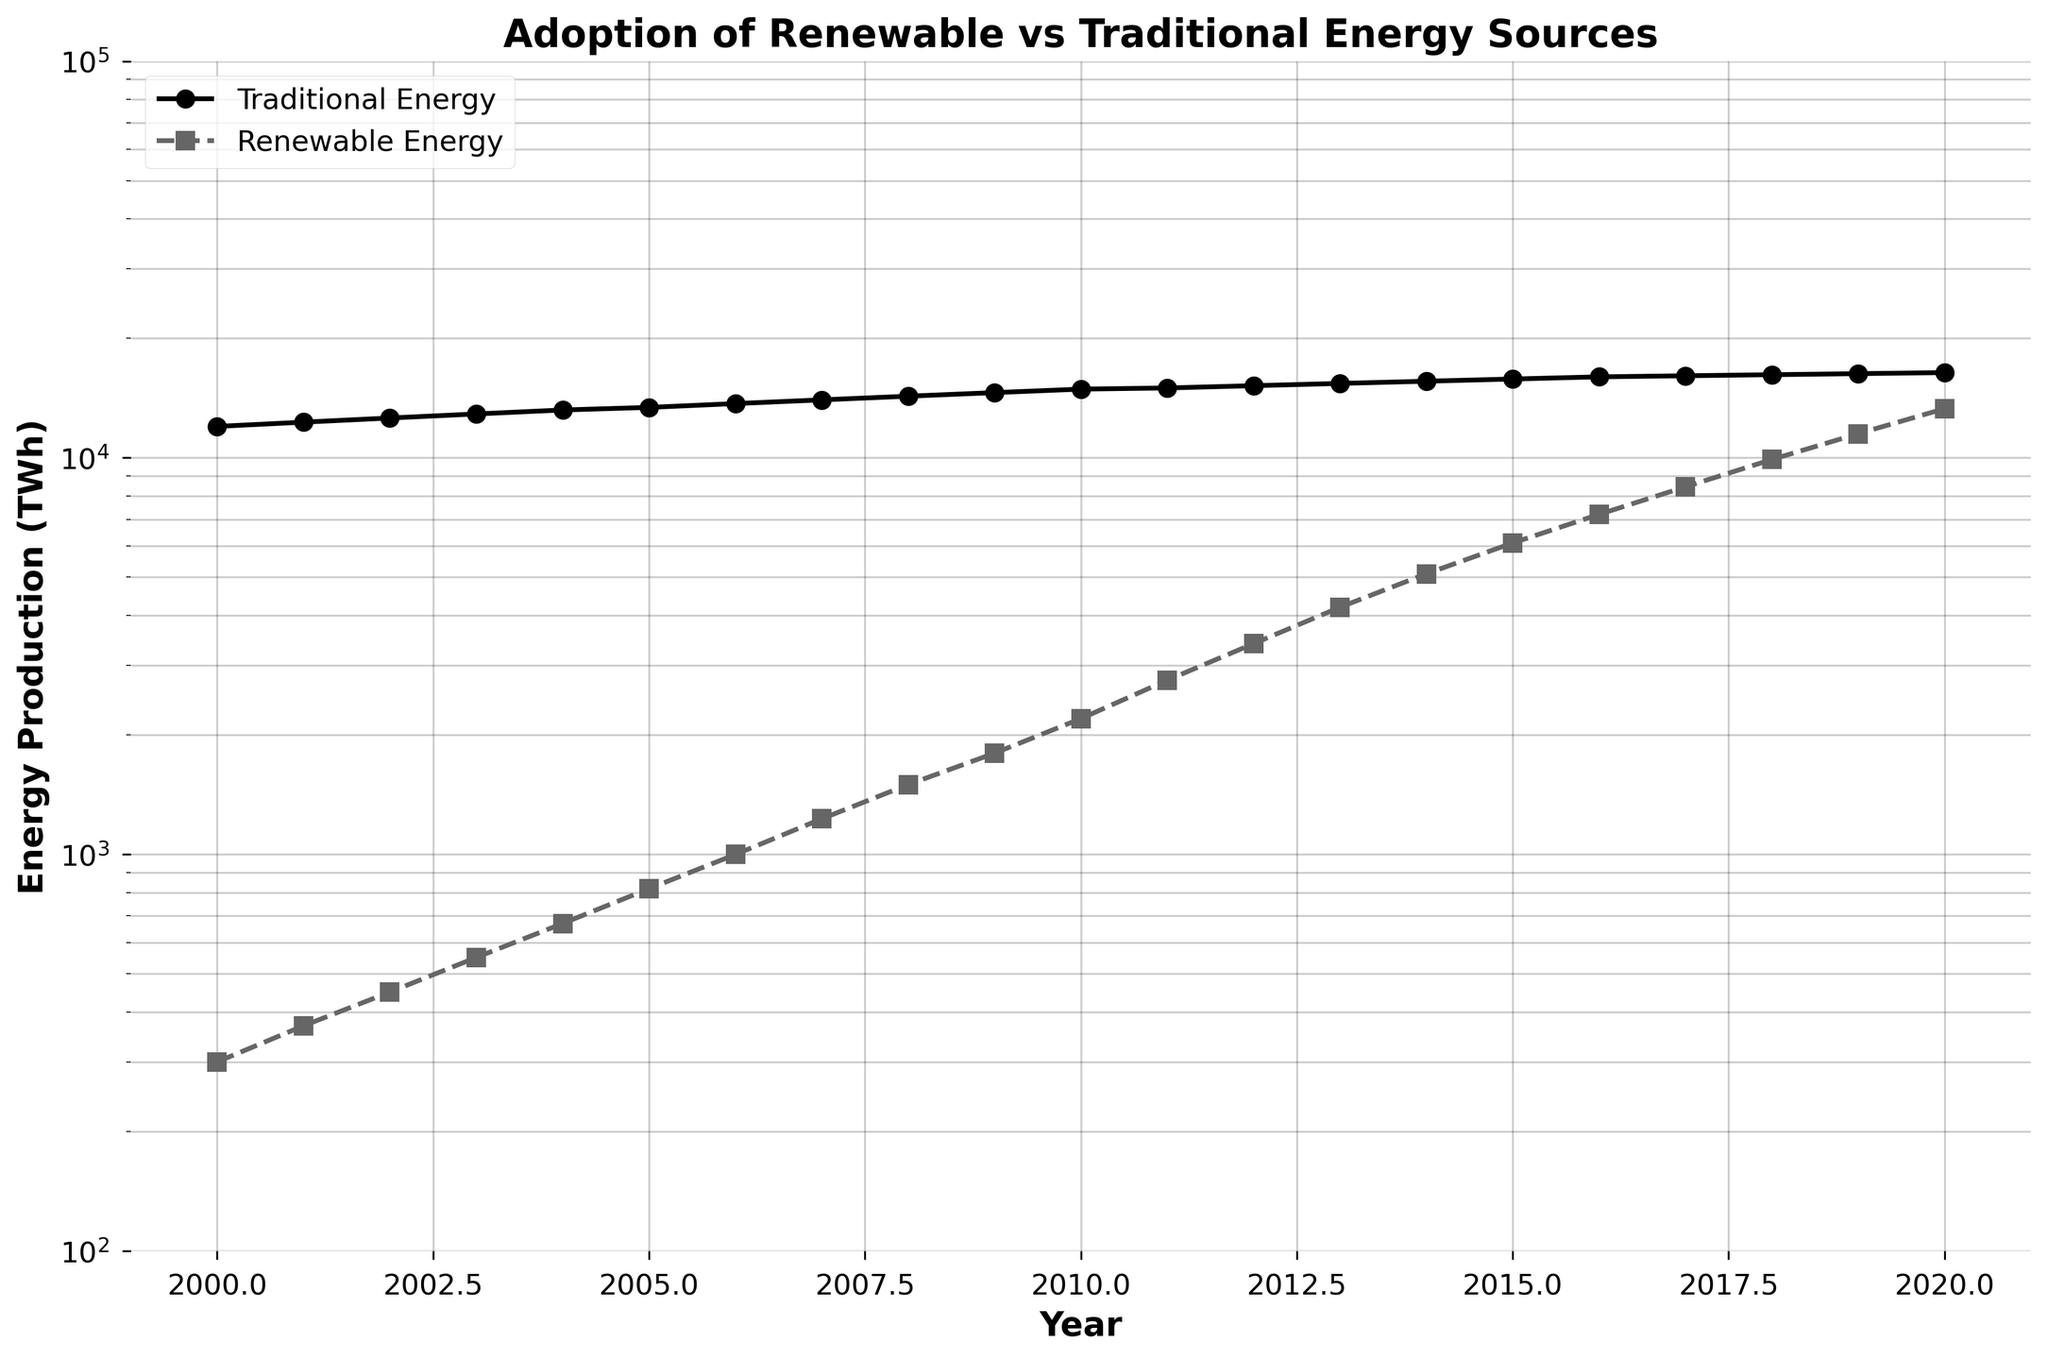what is the title of the plot? The title is found at the top of the plot. Here, it states "Adoption of Renewable vs Traditional Energy Sources".
Answer: Adoption of Renewable vs Traditional Energy Sources What period of years does the data cover? The x-axis of the plot shows the range of years represented in the data. The data spans from the year 2000 to 2020.
Answer: 2000 to 2020 What is the energy production value for traditional energy in the year 2010? Look at the plot where the x-axis intersects with 2010 and then check the corresponding y-value for the "Traditional Energy" line, which is marked with circles.
Answer: 14900 TWh By how much did renewable energy production increase between 2005 and 2010? Find the values for renewable energy production in 2005 and 2010 from the plot or data. In 2005, it was 820 TWh, and in 2010, it was 2200 TWh. The difference is 2200 - 820.
Answer: 1380 TWh In which year did renewable energy production surpass 5000 TWh? Trace the renewable energy line (dashed line) upwards to see when it first passes the 5000 TWh y-axis value and then check the corresponding x-axis value (year). This occurs in 2014.
Answer: 2014 Is the growth trend of renewable energy production steeper than that of traditional energy? Compare the slopes of the lines representing renewable and traditional energy on the plot. The renewable energy line has a steeper slope, indicating faster growth.
Answer: Yes How many times greater was the traditional energy production compared to renewable energy in 2020? Look at the production values for both types in 2020. Traditional is 16400 TWh, and renewable is 13300 TWh. Divide traditional by renewable to find the ratio. 16400 / 13300 is approximately 1.23 times.
Answer: 1.23 times What is the approximate value of renewable energy production in 2016? Locate 2016 on the x-axis, then look at the y-value for the renewable energy line (dashed line) at that point, which is around 7200 TWh.
Answer: 7200 TWh Which energy source had a larger percentage increase from 2000 to 2020? For traditional energy: (16400-12000)/12000 * 100 ≈ 36.7%. For renewable energy: (13300-300)/300 * 100 ≈ 4333%. Renewable energy had a much larger percentage increase.
Answer: Renewable energy How does the use of a logarithmic scale impact the appearance of growth trends on this plot? A logarithmic scale compresses the y-axis, making multiplicative growth appear linear. This helps visualize exponential trends more effectively by reducing the steepness of the curves.
Answer: Compresses and linearizes growth trends 